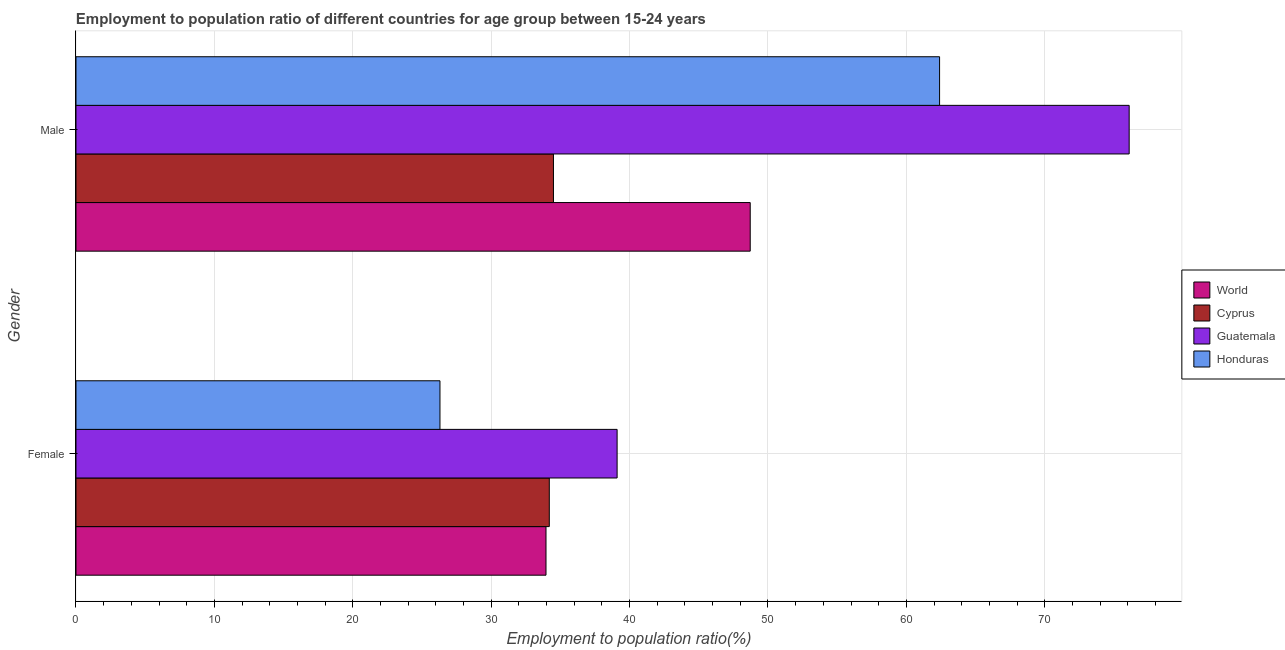How many groups of bars are there?
Make the answer very short. 2. How many bars are there on the 2nd tick from the top?
Your answer should be compact. 4. How many bars are there on the 2nd tick from the bottom?
Ensure brevity in your answer.  4. What is the label of the 1st group of bars from the top?
Your response must be concise. Male. What is the employment to population ratio(female) in Guatemala?
Ensure brevity in your answer.  39.1. Across all countries, what is the maximum employment to population ratio(female)?
Provide a succinct answer. 39.1. Across all countries, what is the minimum employment to population ratio(male)?
Your answer should be compact. 34.5. In which country was the employment to population ratio(female) maximum?
Keep it short and to the point. Guatemala. In which country was the employment to population ratio(female) minimum?
Your answer should be compact. Honduras. What is the total employment to population ratio(male) in the graph?
Provide a short and direct response. 221.72. What is the difference between the employment to population ratio(female) in Guatemala and that in World?
Make the answer very short. 5.14. What is the difference between the employment to population ratio(male) in Honduras and the employment to population ratio(female) in Cyprus?
Give a very brief answer. 28.2. What is the average employment to population ratio(female) per country?
Ensure brevity in your answer.  33.39. What is the difference between the employment to population ratio(male) and employment to population ratio(female) in Honduras?
Your response must be concise. 36.1. In how many countries, is the employment to population ratio(male) greater than 24 %?
Your answer should be very brief. 4. What is the ratio of the employment to population ratio(male) in Guatemala to that in Honduras?
Keep it short and to the point. 1.22. Is the employment to population ratio(female) in Guatemala less than that in Cyprus?
Make the answer very short. No. What does the 1st bar from the top in Male represents?
Your answer should be compact. Honduras. Does the graph contain any zero values?
Keep it short and to the point. No. Where does the legend appear in the graph?
Your answer should be very brief. Center right. How are the legend labels stacked?
Offer a very short reply. Vertical. What is the title of the graph?
Provide a succinct answer. Employment to population ratio of different countries for age group between 15-24 years. Does "Korea (Republic)" appear as one of the legend labels in the graph?
Make the answer very short. No. What is the label or title of the Y-axis?
Your answer should be very brief. Gender. What is the Employment to population ratio(%) in World in Female?
Your answer should be compact. 33.96. What is the Employment to population ratio(%) in Cyprus in Female?
Keep it short and to the point. 34.2. What is the Employment to population ratio(%) of Guatemala in Female?
Give a very brief answer. 39.1. What is the Employment to population ratio(%) in Honduras in Female?
Ensure brevity in your answer.  26.3. What is the Employment to population ratio(%) in World in Male?
Offer a very short reply. 48.72. What is the Employment to population ratio(%) of Cyprus in Male?
Provide a succinct answer. 34.5. What is the Employment to population ratio(%) of Guatemala in Male?
Give a very brief answer. 76.1. What is the Employment to population ratio(%) of Honduras in Male?
Ensure brevity in your answer.  62.4. Across all Gender, what is the maximum Employment to population ratio(%) in World?
Your response must be concise. 48.72. Across all Gender, what is the maximum Employment to population ratio(%) in Cyprus?
Ensure brevity in your answer.  34.5. Across all Gender, what is the maximum Employment to population ratio(%) in Guatemala?
Offer a very short reply. 76.1. Across all Gender, what is the maximum Employment to population ratio(%) in Honduras?
Your response must be concise. 62.4. Across all Gender, what is the minimum Employment to population ratio(%) of World?
Your response must be concise. 33.96. Across all Gender, what is the minimum Employment to population ratio(%) in Cyprus?
Offer a very short reply. 34.2. Across all Gender, what is the minimum Employment to population ratio(%) of Guatemala?
Keep it short and to the point. 39.1. Across all Gender, what is the minimum Employment to population ratio(%) of Honduras?
Your response must be concise. 26.3. What is the total Employment to population ratio(%) in World in the graph?
Provide a short and direct response. 82.68. What is the total Employment to population ratio(%) in Cyprus in the graph?
Ensure brevity in your answer.  68.7. What is the total Employment to population ratio(%) in Guatemala in the graph?
Ensure brevity in your answer.  115.2. What is the total Employment to population ratio(%) of Honduras in the graph?
Your response must be concise. 88.7. What is the difference between the Employment to population ratio(%) in World in Female and that in Male?
Give a very brief answer. -14.76. What is the difference between the Employment to population ratio(%) of Guatemala in Female and that in Male?
Make the answer very short. -37. What is the difference between the Employment to population ratio(%) in Honduras in Female and that in Male?
Ensure brevity in your answer.  -36.1. What is the difference between the Employment to population ratio(%) in World in Female and the Employment to population ratio(%) in Cyprus in Male?
Offer a terse response. -0.54. What is the difference between the Employment to population ratio(%) of World in Female and the Employment to population ratio(%) of Guatemala in Male?
Your answer should be compact. -42.14. What is the difference between the Employment to population ratio(%) of World in Female and the Employment to population ratio(%) of Honduras in Male?
Provide a short and direct response. -28.44. What is the difference between the Employment to population ratio(%) in Cyprus in Female and the Employment to population ratio(%) in Guatemala in Male?
Provide a succinct answer. -41.9. What is the difference between the Employment to population ratio(%) in Cyprus in Female and the Employment to population ratio(%) in Honduras in Male?
Ensure brevity in your answer.  -28.2. What is the difference between the Employment to population ratio(%) of Guatemala in Female and the Employment to population ratio(%) of Honduras in Male?
Offer a very short reply. -23.3. What is the average Employment to population ratio(%) in World per Gender?
Your answer should be compact. 41.34. What is the average Employment to population ratio(%) in Cyprus per Gender?
Provide a succinct answer. 34.35. What is the average Employment to population ratio(%) in Guatemala per Gender?
Give a very brief answer. 57.6. What is the average Employment to population ratio(%) in Honduras per Gender?
Provide a succinct answer. 44.35. What is the difference between the Employment to population ratio(%) of World and Employment to population ratio(%) of Cyprus in Female?
Your response must be concise. -0.24. What is the difference between the Employment to population ratio(%) in World and Employment to population ratio(%) in Guatemala in Female?
Ensure brevity in your answer.  -5.14. What is the difference between the Employment to population ratio(%) in World and Employment to population ratio(%) in Honduras in Female?
Ensure brevity in your answer.  7.66. What is the difference between the Employment to population ratio(%) of World and Employment to population ratio(%) of Cyprus in Male?
Keep it short and to the point. 14.22. What is the difference between the Employment to population ratio(%) in World and Employment to population ratio(%) in Guatemala in Male?
Keep it short and to the point. -27.38. What is the difference between the Employment to population ratio(%) of World and Employment to population ratio(%) of Honduras in Male?
Your answer should be very brief. -13.68. What is the difference between the Employment to population ratio(%) in Cyprus and Employment to population ratio(%) in Guatemala in Male?
Ensure brevity in your answer.  -41.6. What is the difference between the Employment to population ratio(%) in Cyprus and Employment to population ratio(%) in Honduras in Male?
Keep it short and to the point. -27.9. What is the difference between the Employment to population ratio(%) in Guatemala and Employment to population ratio(%) in Honduras in Male?
Ensure brevity in your answer.  13.7. What is the ratio of the Employment to population ratio(%) in World in Female to that in Male?
Your answer should be very brief. 0.7. What is the ratio of the Employment to population ratio(%) in Cyprus in Female to that in Male?
Your answer should be compact. 0.99. What is the ratio of the Employment to population ratio(%) in Guatemala in Female to that in Male?
Your answer should be very brief. 0.51. What is the ratio of the Employment to population ratio(%) of Honduras in Female to that in Male?
Offer a very short reply. 0.42. What is the difference between the highest and the second highest Employment to population ratio(%) in World?
Your answer should be compact. 14.76. What is the difference between the highest and the second highest Employment to population ratio(%) in Cyprus?
Give a very brief answer. 0.3. What is the difference between the highest and the second highest Employment to population ratio(%) in Guatemala?
Ensure brevity in your answer.  37. What is the difference between the highest and the second highest Employment to population ratio(%) of Honduras?
Your response must be concise. 36.1. What is the difference between the highest and the lowest Employment to population ratio(%) of World?
Provide a succinct answer. 14.76. What is the difference between the highest and the lowest Employment to population ratio(%) of Honduras?
Offer a terse response. 36.1. 